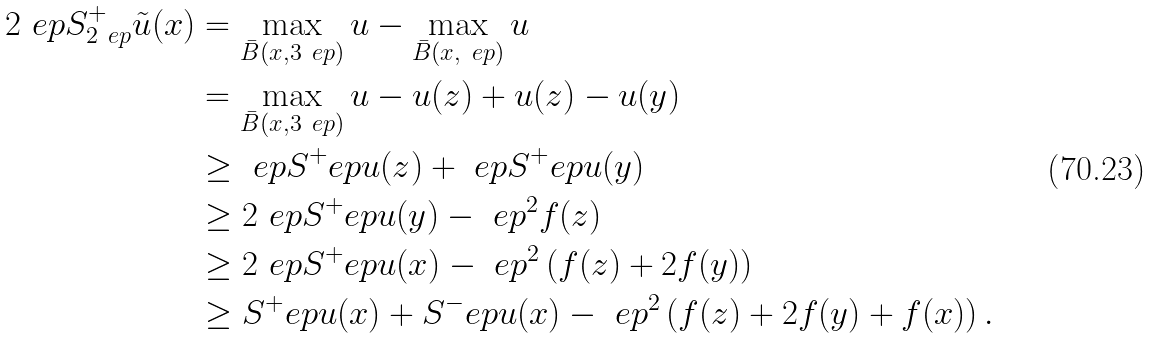Convert formula to latex. <formula><loc_0><loc_0><loc_500><loc_500>2 \ e p S ^ { + } _ { 2 \ e p } \tilde { u } ( x ) & = \max _ { \bar { B } ( x , 3 \ e p ) } u - \max _ { \bar { B } ( x , \ e p ) } u \\ & = \max _ { \bar { B } ( x , 3 \ e p ) } u - u ( z ) + u ( z ) - u ( y ) \\ & \geq \ e p S ^ { + } _ { \ } e p u ( z ) + \ e p S ^ { + } _ { \ } e p u ( y ) \\ & \geq 2 \ e p S ^ { + } _ { \ } e p u ( y ) - \ e p ^ { 2 } f ( z ) \\ & \geq 2 \ e p S ^ { + } _ { \ } e p u ( x ) - \ e p ^ { 2 } \left ( f ( z ) + 2 f ( y ) \right ) \\ & \geq S ^ { + } _ { \ } e p u ( x ) + S ^ { - } _ { \ } e p u ( x ) - \ e p ^ { 2 } \left ( f ( z ) + 2 f ( y ) + f ( x ) \right ) .</formula> 